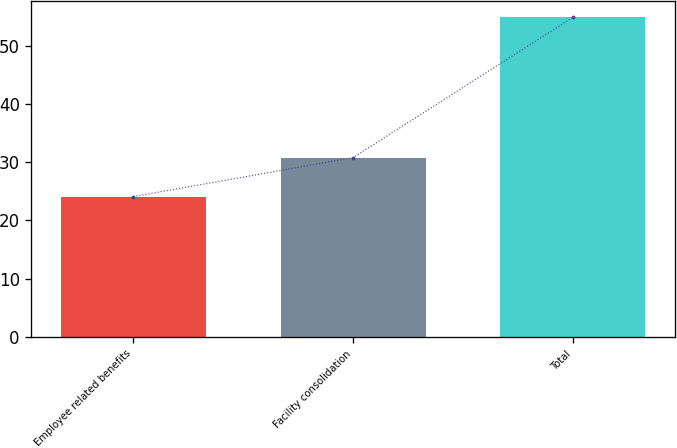Convert chart. <chart><loc_0><loc_0><loc_500><loc_500><bar_chart><fcel>Employee related benefits<fcel>Facility consolidation<fcel>Total<nl><fcel>24.1<fcel>30.8<fcel>54.9<nl></chart> 